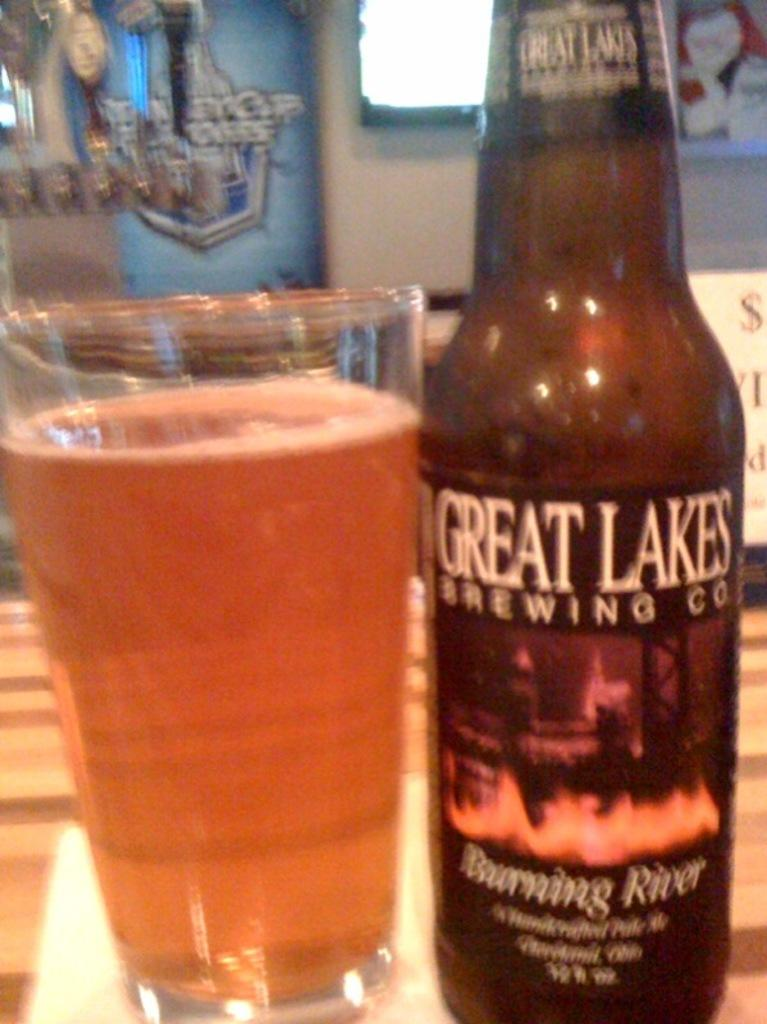<image>
Give a short and clear explanation of the subsequent image. A glass of beer next to a bottle of Great Lakes Brewing Company Burning River ale 